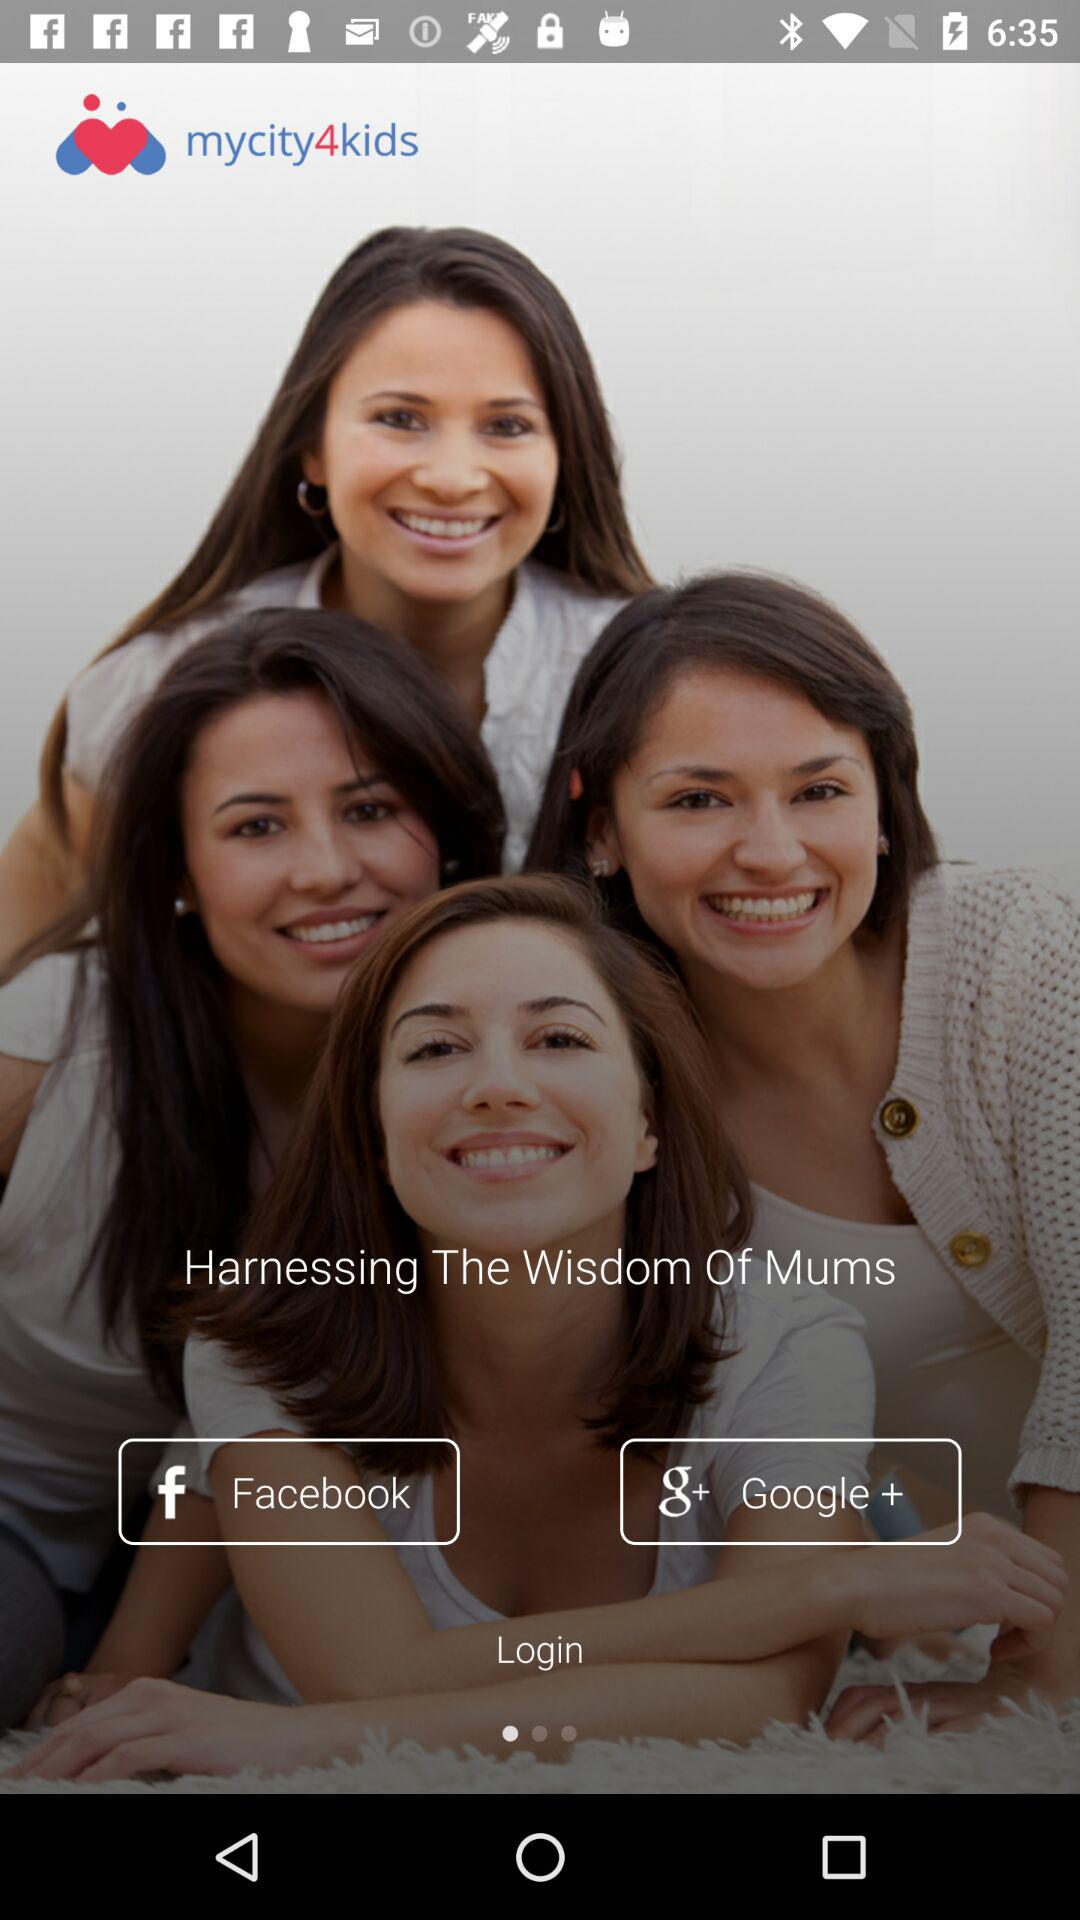Who is this application powered by?
When the provided information is insufficient, respond with <no answer>. <no answer> 